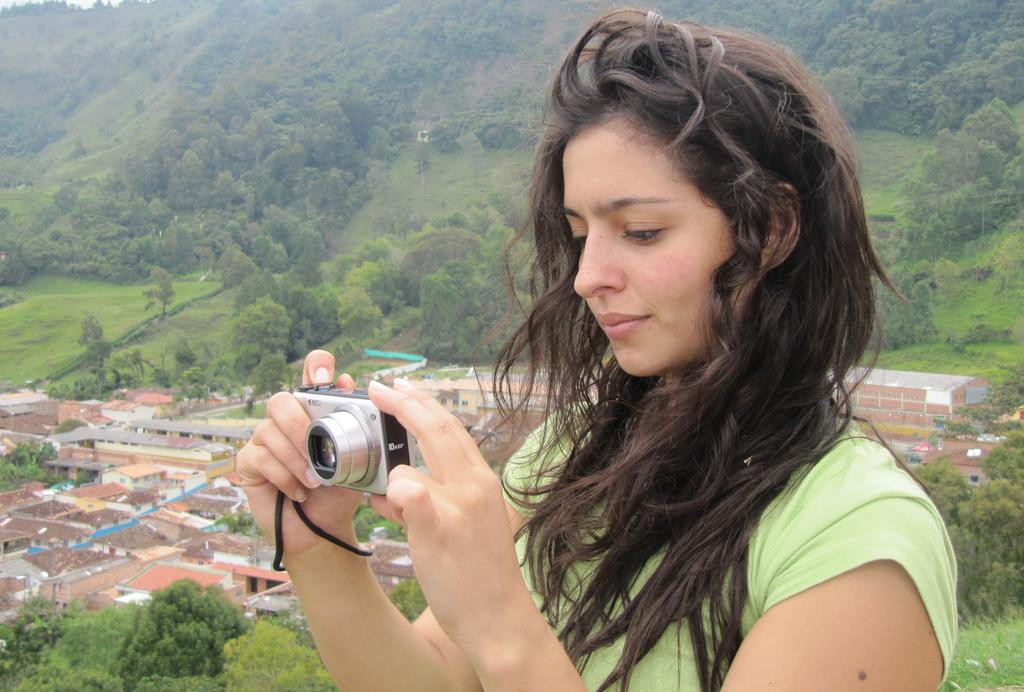Who is the main subject in the image? There is a woman in the image. What is the woman doing in the image? The woman is capturing a picture with a camera. What can be seen in the background of the image? There are buildings, a tree, and a mountain in the background of the image. Can you see the root of the tree in the image? There is no root of the tree visible in the image; only the tree itself is present. 